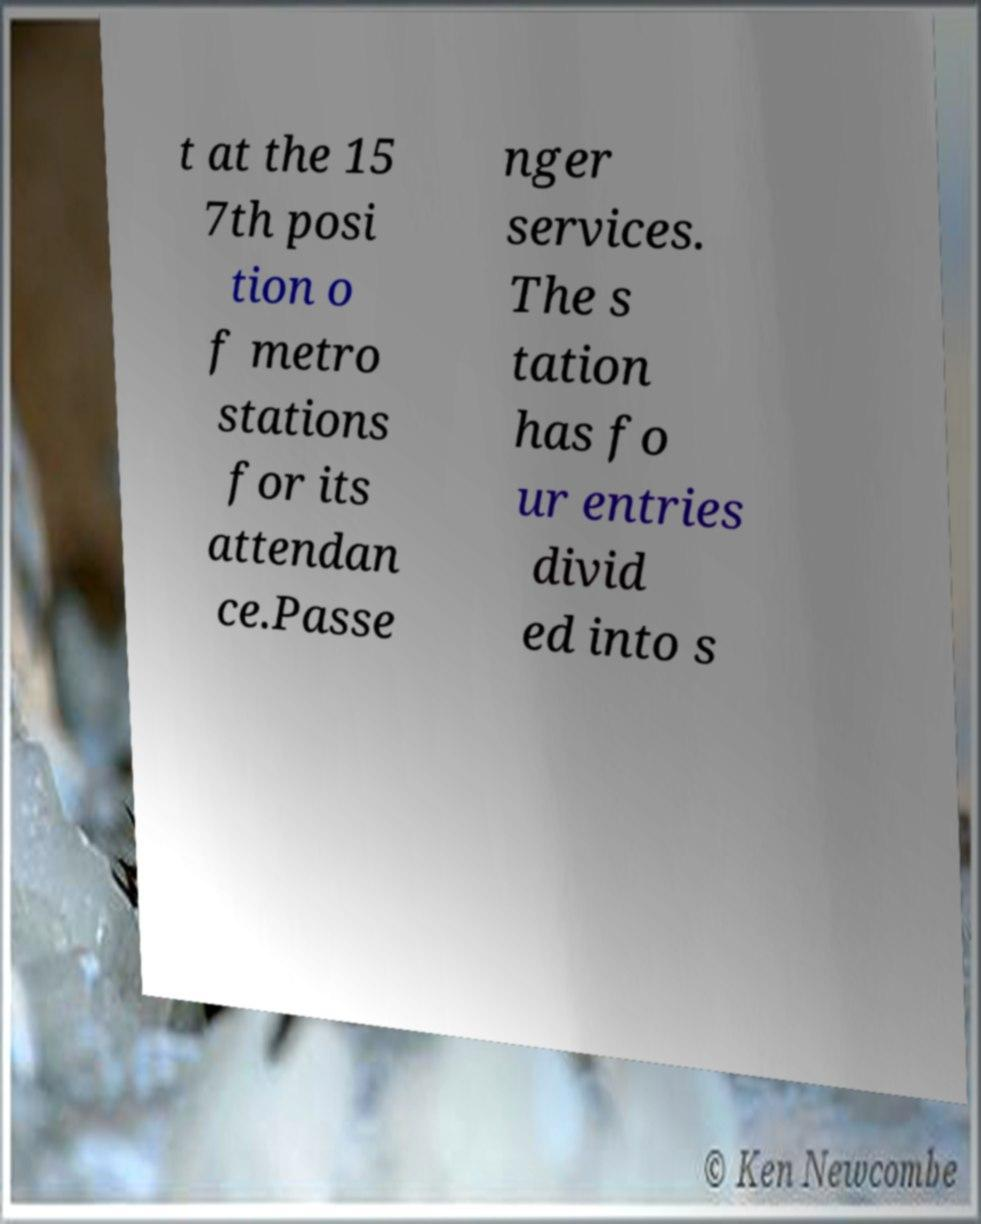Could you assist in decoding the text presented in this image and type it out clearly? t at the 15 7th posi tion o f metro stations for its attendan ce.Passe nger services. The s tation has fo ur entries divid ed into s 